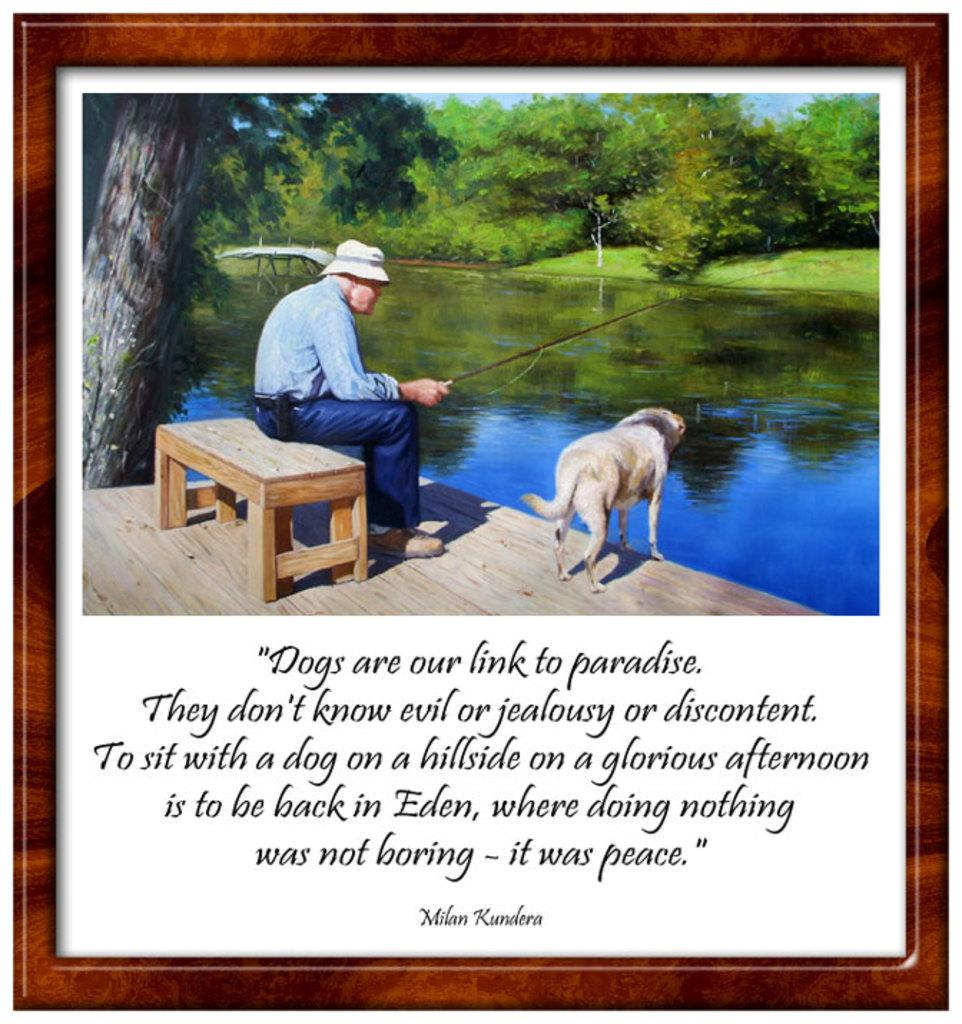<image>
Share a concise interpretation of the image provided. Framed picture of a man fishing with his dog and the name Milan Kundera on the bottom. 